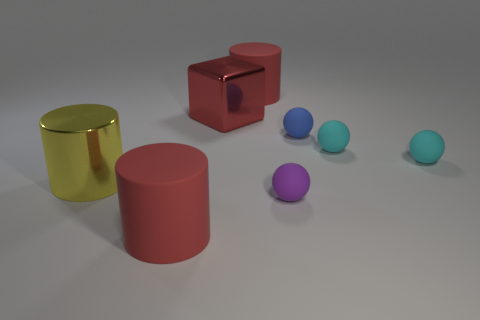Looking at these objects, which ones seem to be the largest and smallest? In this image, the largest objects appear to be the cylinders, given their height and volume, while the smallest objects are the small blue spheres. 